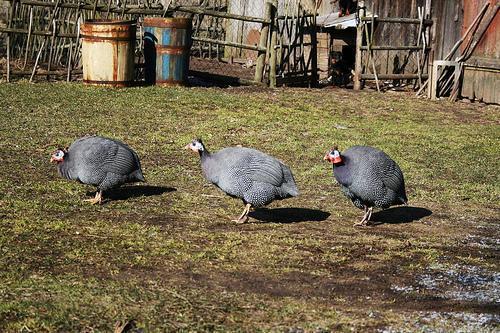What is the brown areas on the barrels?
Make your selection from the four choices given to correctly answer the question.
Options: Animal droppings, rust, syrup stains, paint. Rust. 